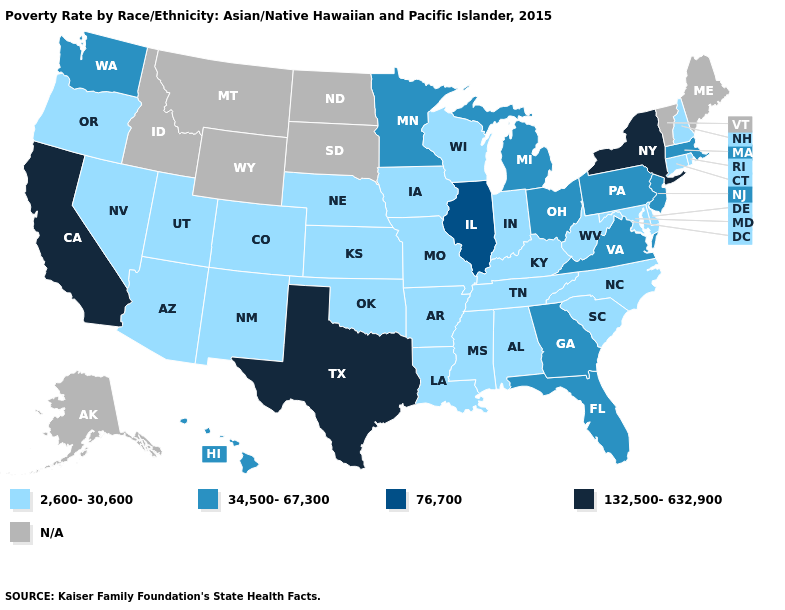Name the states that have a value in the range 34,500-67,300?
Short answer required. Florida, Georgia, Hawaii, Massachusetts, Michigan, Minnesota, New Jersey, Ohio, Pennsylvania, Virginia, Washington. What is the highest value in the South ?
Quick response, please. 132,500-632,900. What is the highest value in the West ?
Be succinct. 132,500-632,900. Name the states that have a value in the range 2,600-30,600?
Answer briefly. Alabama, Arizona, Arkansas, Colorado, Connecticut, Delaware, Indiana, Iowa, Kansas, Kentucky, Louisiana, Maryland, Mississippi, Missouri, Nebraska, Nevada, New Hampshire, New Mexico, North Carolina, Oklahoma, Oregon, Rhode Island, South Carolina, Tennessee, Utah, West Virginia, Wisconsin. What is the lowest value in the USA?
Concise answer only. 2,600-30,600. Among the states that border Delaware , does New Jersey have the lowest value?
Keep it brief. No. Among the states that border New York , which have the highest value?
Keep it brief. Massachusetts, New Jersey, Pennsylvania. Does Georgia have the lowest value in the USA?
Concise answer only. No. What is the value of West Virginia?
Short answer required. 2,600-30,600. Does Kentucky have the highest value in the South?
Write a very short answer. No. What is the value of Maine?
Write a very short answer. N/A. What is the value of Virginia?
Be succinct. 34,500-67,300. Is the legend a continuous bar?
Answer briefly. No. Does the map have missing data?
Concise answer only. Yes. Does Texas have the highest value in the USA?
Answer briefly. Yes. 